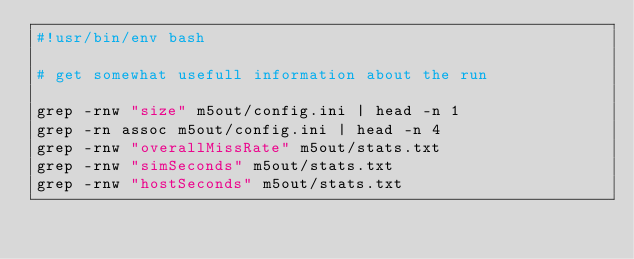Convert code to text. <code><loc_0><loc_0><loc_500><loc_500><_Bash_>#!usr/bin/env bash

# get somewhat usefull information about the run

grep -rnw "size" m5out/config.ini | head -n 1
grep -rn assoc m5out/config.ini | head -n 4
grep -rnw "overallMissRate" m5out/stats.txt
grep -rnw "simSeconds" m5out/stats.txt
grep -rnw "hostSeconds" m5out/stats.txt
</code> 